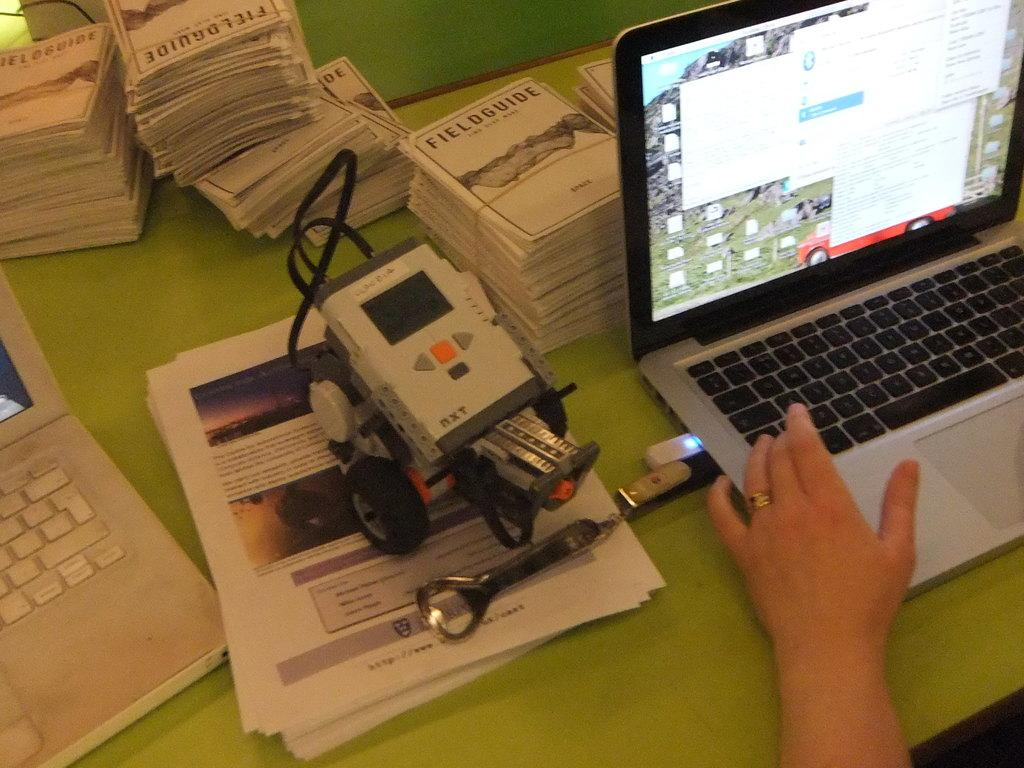<image>
Create a compact narrative representing the image presented. Two laptops with a stack of fieldguides behind them. 